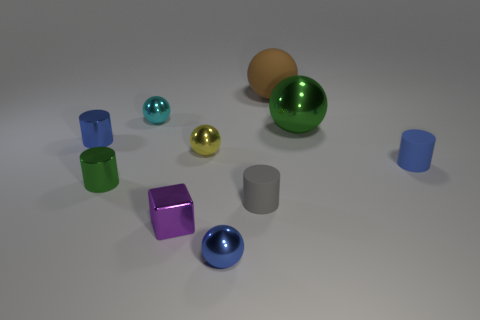Are there the same number of yellow spheres that are in front of the large green metallic object and matte balls?
Keep it short and to the point. Yes. What shape is the metallic thing that is both in front of the green sphere and behind the tiny yellow thing?
Make the answer very short. Cylinder. Do the green shiny sphere and the brown rubber ball have the same size?
Offer a terse response. Yes. Are there any other tiny objects made of the same material as the tiny green thing?
Offer a very short reply. Yes. There is a cylinder that is the same color as the large metal sphere; what size is it?
Make the answer very short. Small. What number of blue objects are behind the small green metallic cylinder and right of the tiny block?
Make the answer very short. 1. There is a green thing that is to the left of the large metal thing; what is it made of?
Provide a succinct answer. Metal. How many other blocks are the same color as the small cube?
Your answer should be compact. 0. What is the size of the cyan thing that is made of the same material as the big green thing?
Offer a very short reply. Small. What number of objects are either purple shiny objects or shiny spheres?
Make the answer very short. 5. 